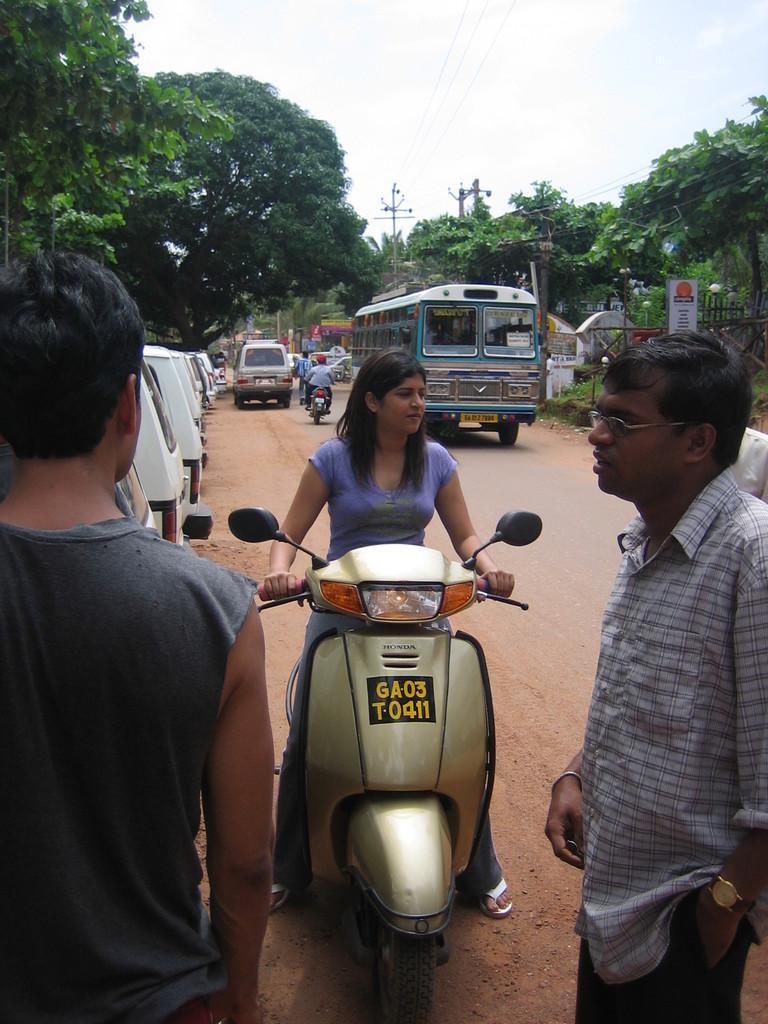Please provide a concise description of this image. In the picture we can see two men are standing on the path and a woman sitting on the bike and holding the handle and she is wearing a violet T-shirt and in the background we can see some vans are parked on the path and we can also see a bus on the road and some people on the bike and cars, and we can also see some trees on the either side of the road and some current poles with wires and a sky with clouds. 